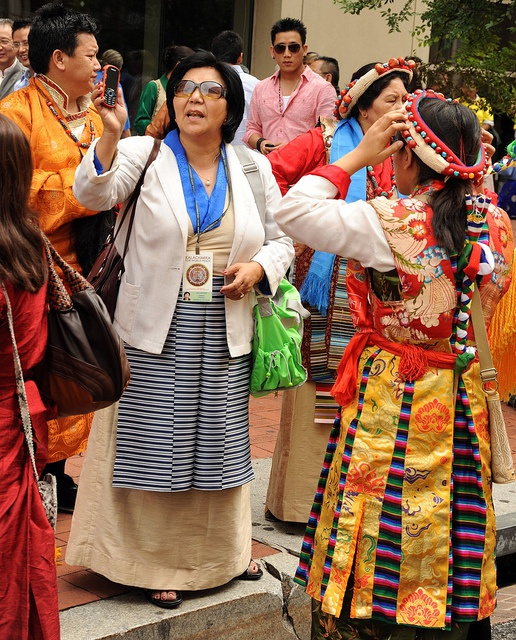Describe the objects in this image and their specific colors. I can see people in black, red, tan, and orange tones, people in black, tan, lightgray, and darkgray tones, people in black, brown, and maroon tones, people in black, red, and orange tones, and handbag in black, maroon, and gray tones in this image. 